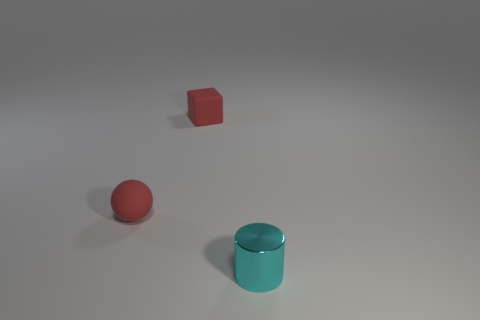Add 2 tiny red rubber blocks. How many objects exist? 5 Subtract all spheres. How many objects are left? 2 Subtract all tiny blocks. Subtract all red spheres. How many objects are left? 1 Add 2 small cyan objects. How many small cyan objects are left? 3 Add 2 rubber balls. How many rubber balls exist? 3 Subtract 0 blue cylinders. How many objects are left? 3 